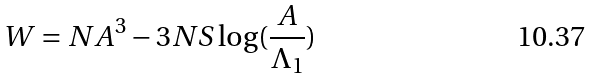Convert formula to latex. <formula><loc_0><loc_0><loc_500><loc_500>W = N A ^ { 3 } - 3 N S \log ( \frac { A } { \Lambda _ { 1 } } )</formula> 